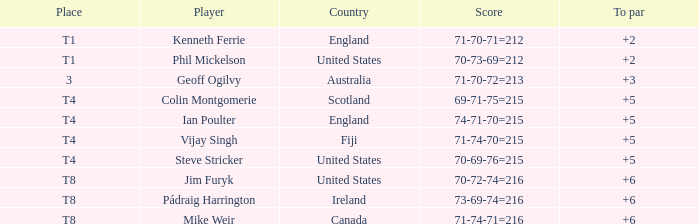What player was place of t1 in To Par and had a score of 70-73-69=212? 2.0. 